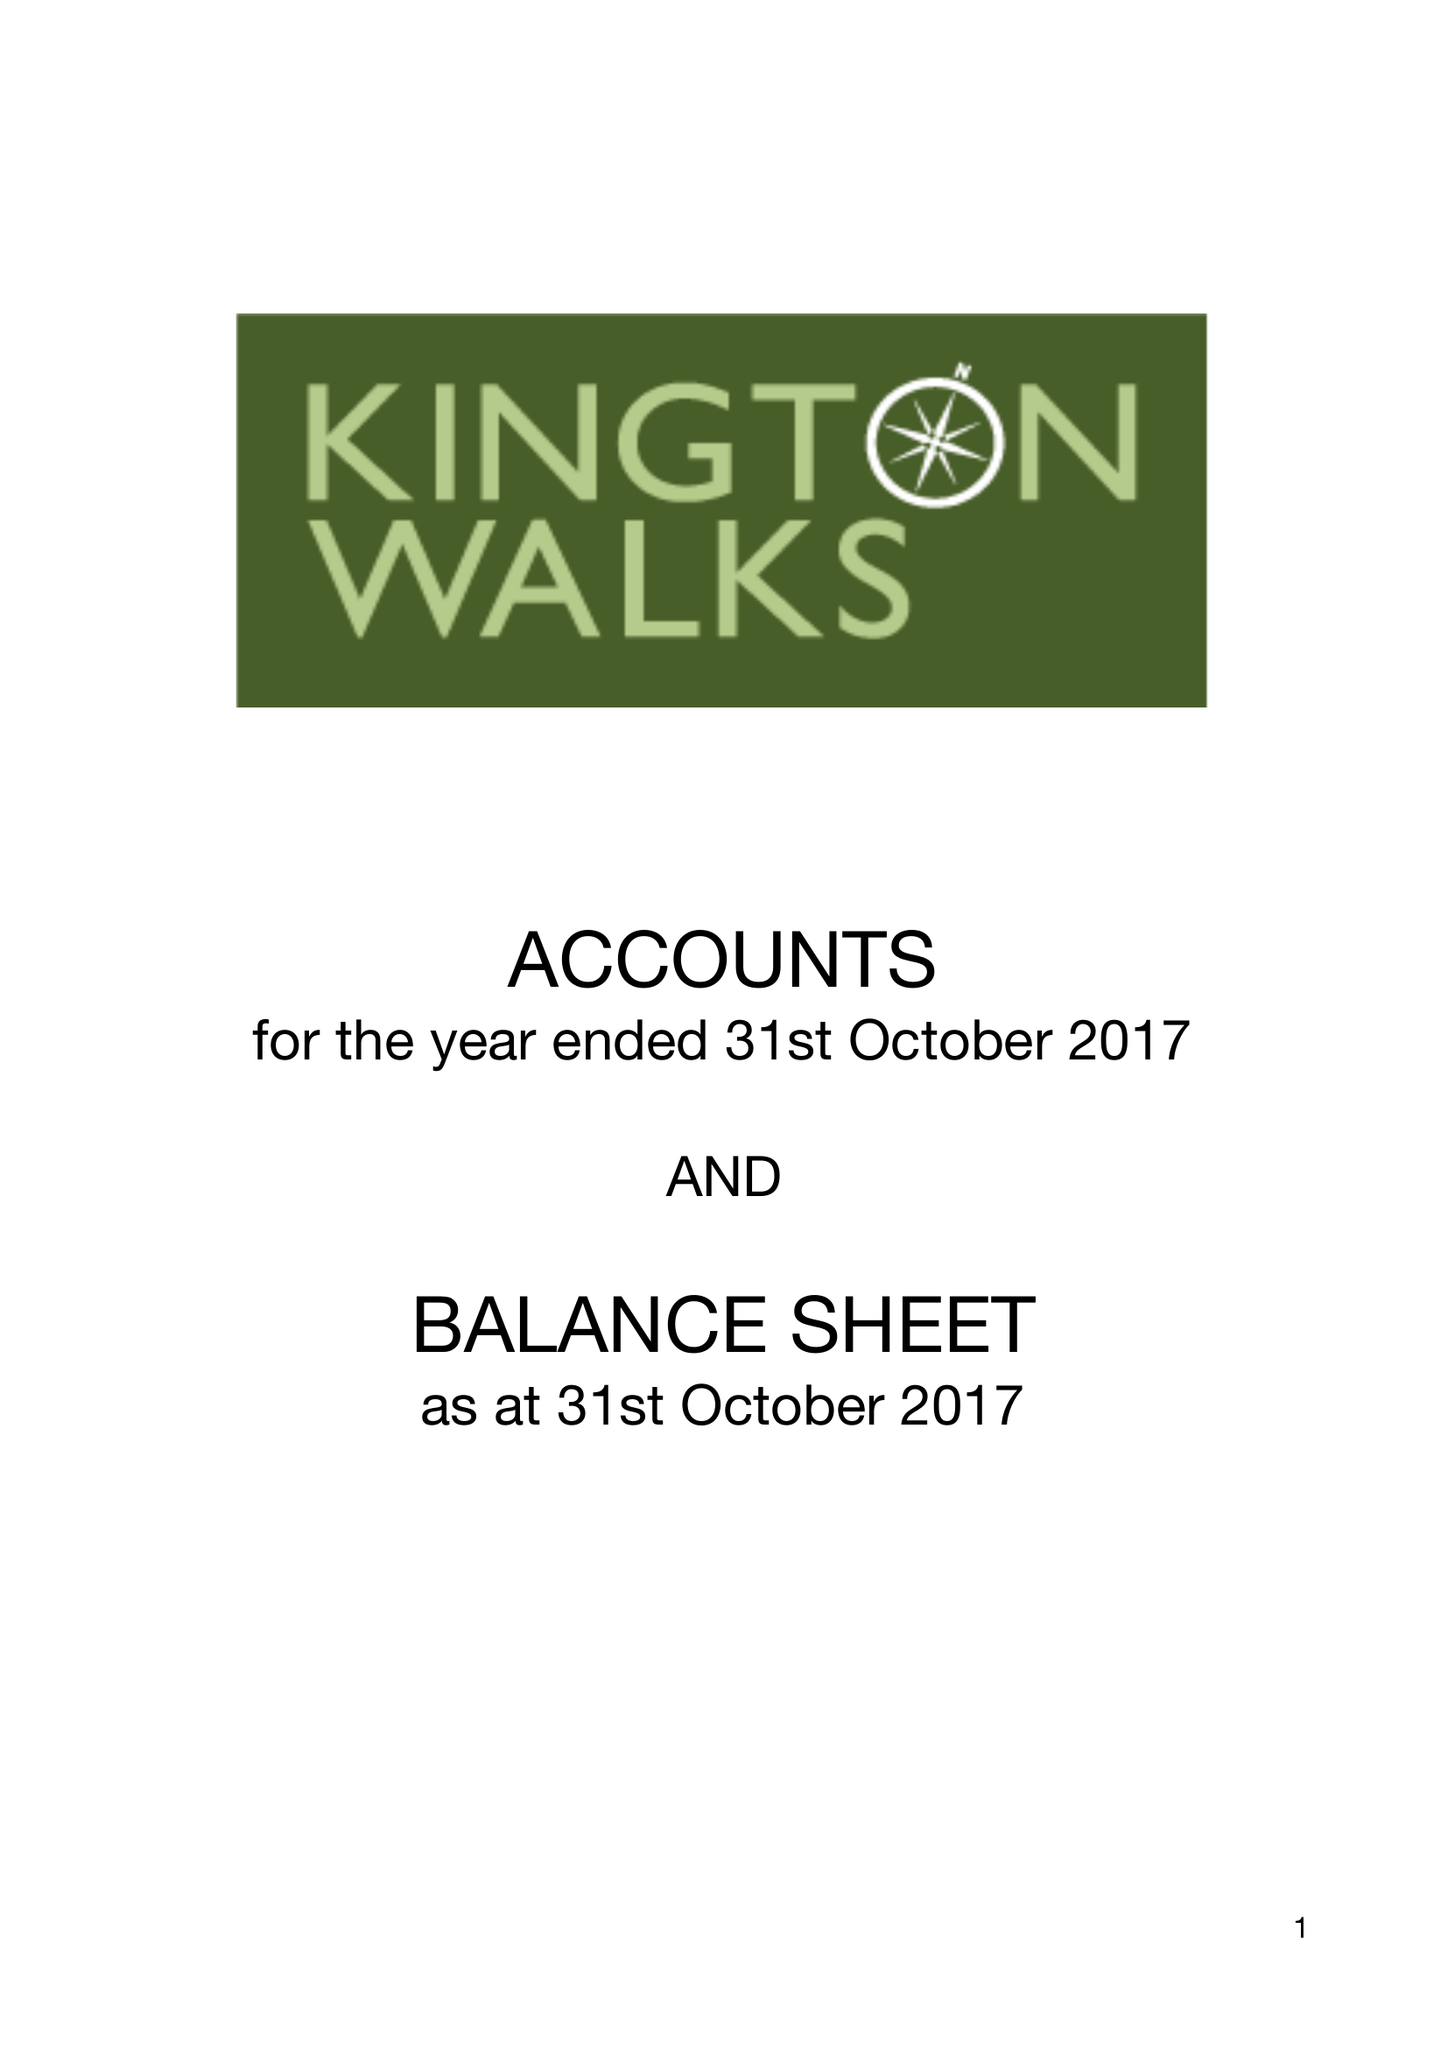What is the value for the spending_annually_in_british_pounds?
Answer the question using a single word or phrase. 8849.00 